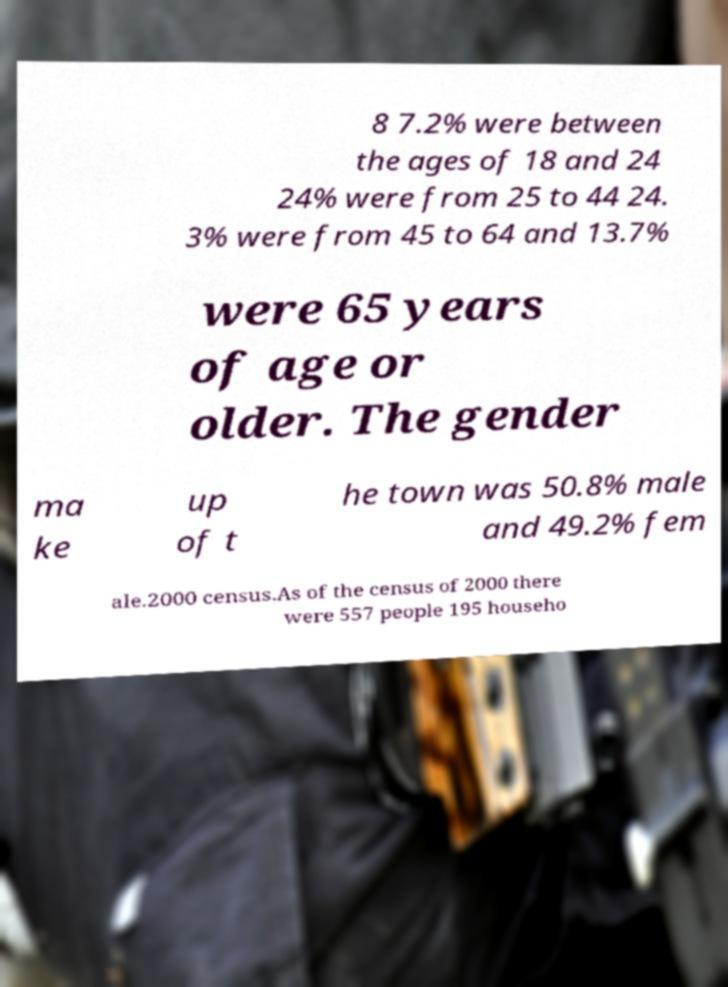Could you extract and type out the text from this image? 8 7.2% were between the ages of 18 and 24 24% were from 25 to 44 24. 3% were from 45 to 64 and 13.7% were 65 years of age or older. The gender ma ke up of t he town was 50.8% male and 49.2% fem ale.2000 census.As of the census of 2000 there were 557 people 195 househo 